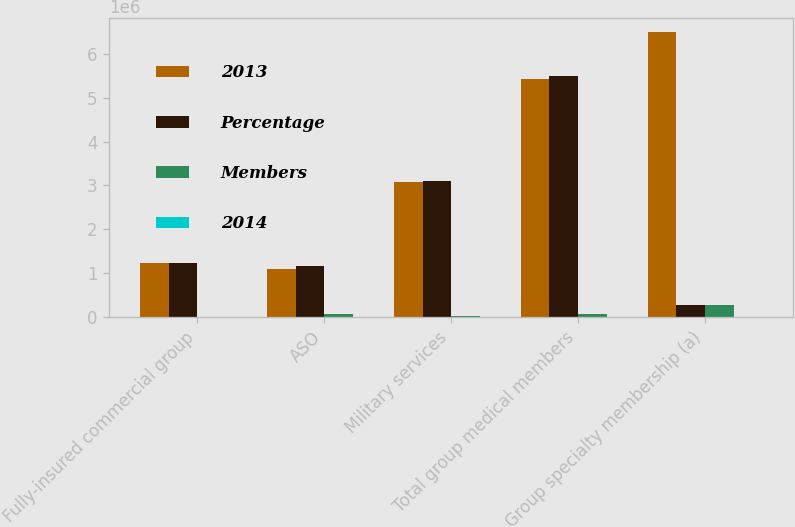Convert chart to OTSL. <chart><loc_0><loc_0><loc_500><loc_500><stacked_bar_chart><ecel><fcel>Fully-insured commercial group<fcel>ASO<fcel>Military services<fcel>Total group medical members<fcel>Group specialty membership (a)<nl><fcel>2013<fcel>1.2355e+06<fcel>1.1043e+06<fcel>3.0904e+06<fcel>5.4302e+06<fcel>6.5027e+06<nl><fcel>Percentage<fcel>1.237e+06<fcel>1.1628e+06<fcel>3.1018e+06<fcel>5.5016e+06<fcel>278100<nl><fcel>Members<fcel>1500<fcel>58500<fcel>11400<fcel>71400<fcel>278100<nl><fcel>2014<fcel>0.1<fcel>5<fcel>0.4<fcel>1.3<fcel>4.1<nl></chart> 